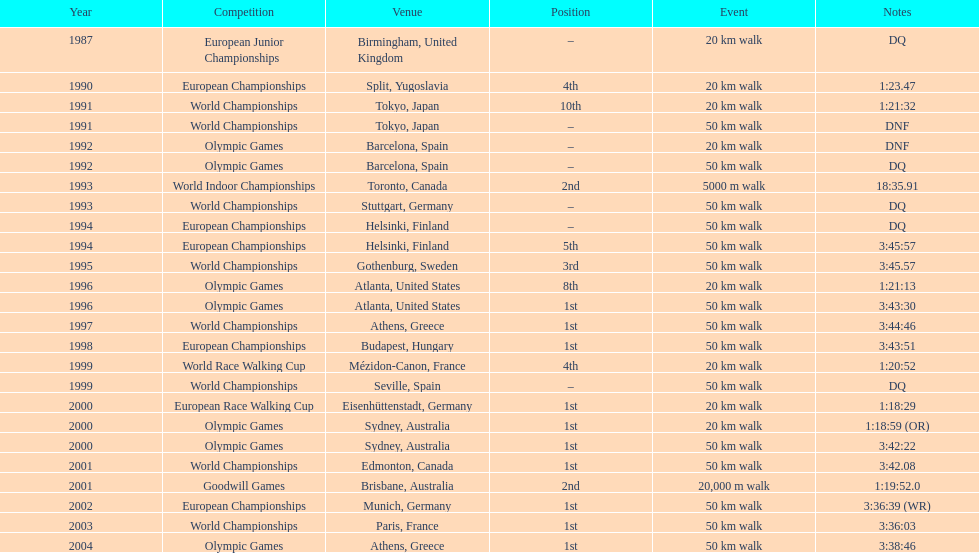How long did it take to walk 50 km in the 2004 olympic games? 3:38:46. 